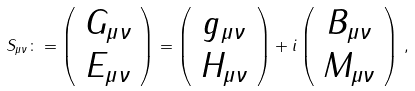Convert formula to latex. <formula><loc_0><loc_0><loc_500><loc_500>S _ { \mu \nu } \colon = \left ( \begin{array} { c } { { G _ { \mu \nu } } } \\ { { E _ { \mu \nu } } } \end{array} \right ) = \left ( \begin{array} { c } { { g _ { \mu \nu } } } \\ { { H _ { \mu \nu } } } \end{array} \right ) + i \left ( \begin{array} { c } { { B _ { \mu \nu } } } \\ { { M _ { \mu \nu } } } \end{array} \right ) \, ,</formula> 